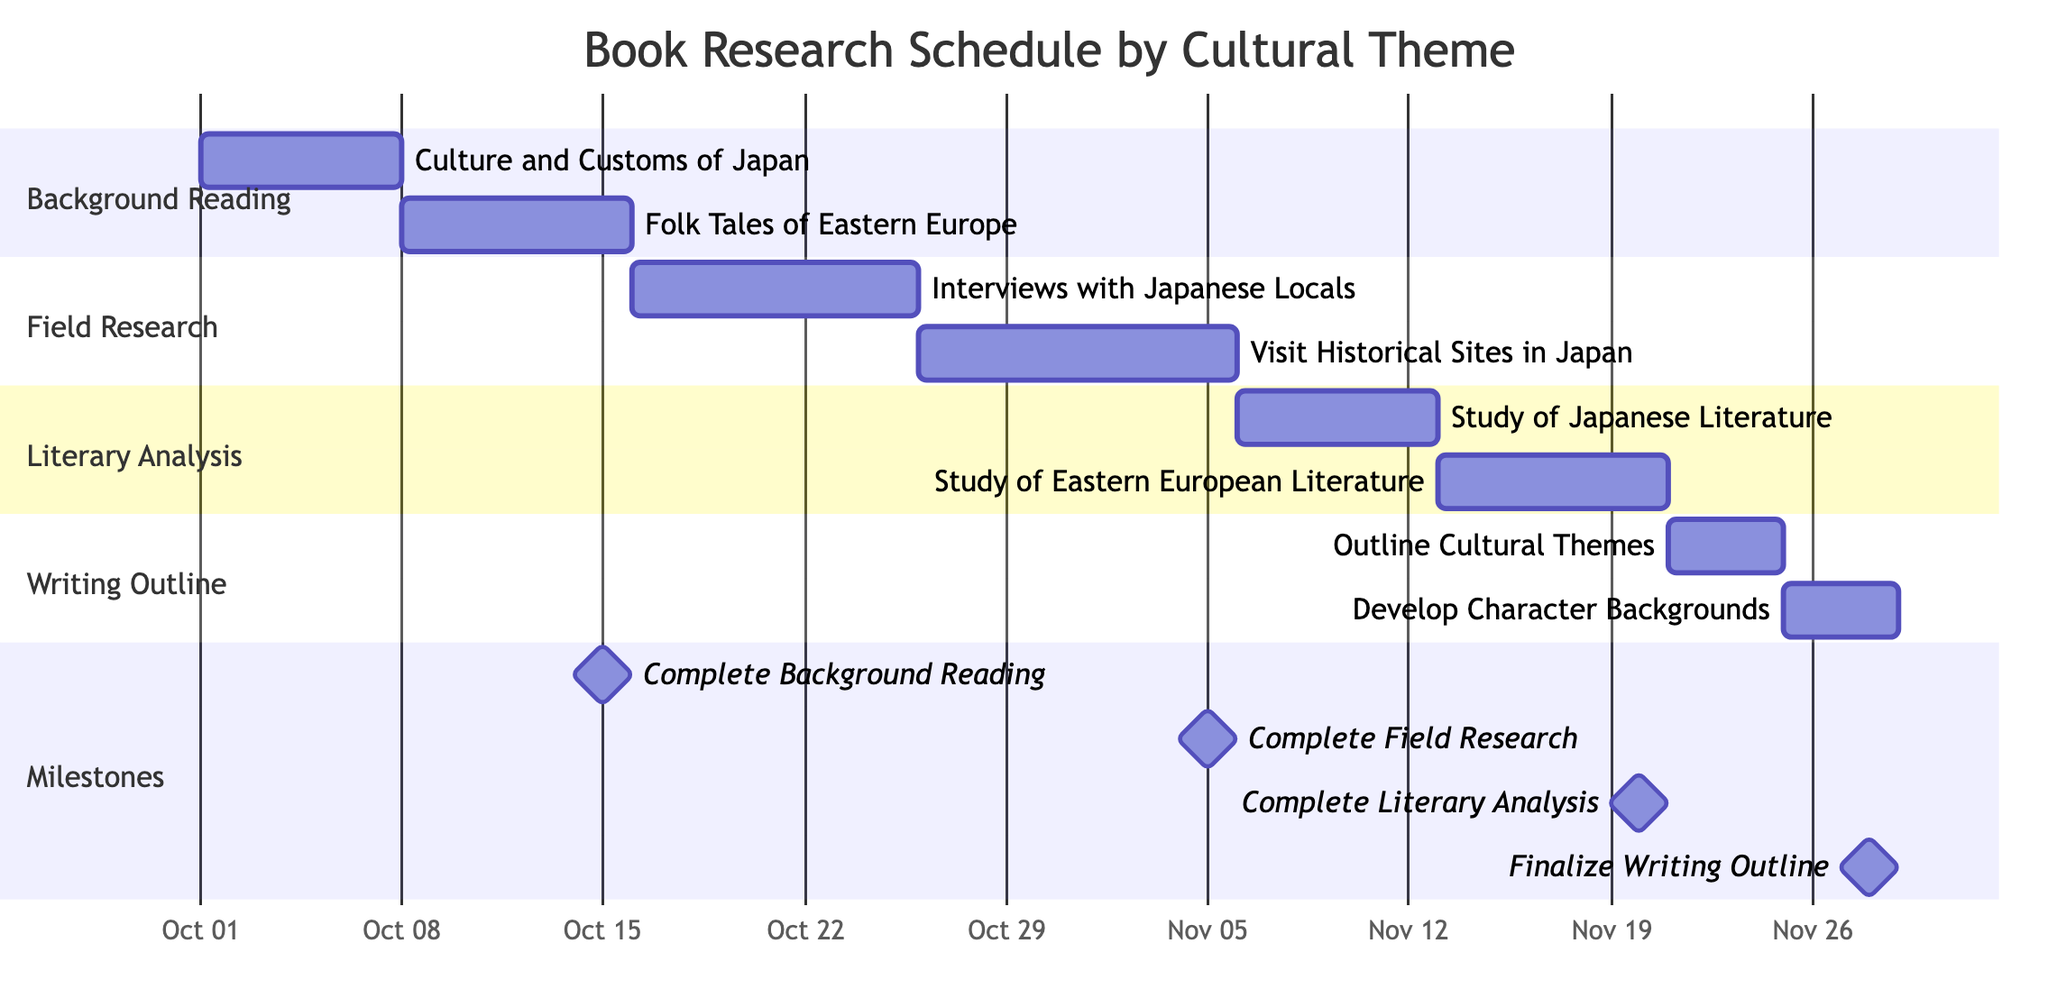What is the duration of the "Background Reading" task? The "Background Reading" task starts on October 1, 2023, and ends on October 15, 2023. To find the duration, we calculate the difference: October 15 - October 1 = 14 days.
Answer: 14 days What are the two subtasks under "Field Research"? The subtasks under "Field Research" are shown as distinct tasks: "Interviews with Japanese Locals" and "Visit Historical Sites in Japan." They are directly listed under the "Field Research" section.
Answer: Interviews with Japanese Locals, Visit Historical Sites in Japan What is the completion date for the "Complete Literary Analysis" milestone? The milestone "Complete Literary Analysis" is clearly indicated with a specific date. According to the diagram, it is set for November 20, 2023.
Answer: November 20, 2023 How many total tasks are there in the “Writing Outline” section? In the "Writing Outline" section, there are two listed tasks: "Outline Cultural Themes" and "Develop Character Backgrounds." This total is simply counted from the entries under that section.
Answer: 2 What is the earliest start date among all tasks? By reviewing all the start dates listed: October 1 (Background Reading), October 16 (Field Research), November 6 (Literary Analysis), and November 21 (Writing Outline), the earliest date is October 1, 2023.
Answer: October 1, 2023 Which subtask finishes last in the overall schedule? To identify the last finishing subtask, we examine all end dates. The last subtask is "Develop Character Backgrounds," which ends on November 28, 2023, noted in the "Writing Outline" section.
Answer: November 28, 2023 How many days does the "Interviews with Japanese Locals" task last? The task "Interviews with Japanese Locals" begins on October 16, 2023, and concludes on October 25, 2023. The duration is calculated as October 25 - October 16, yielding a total of 10 days.
Answer: 10 days What task overlaps with the "Study of Japanese Literature"? By looking at the timeline, note that "Study of Japanese Literature" runs from November 6 to November 12, 2023. The following task, "Study of Eastern European Literature," begins on November 13 and overlaps with no others in the scheduled sections. Therefore, it does not overlap with the preceding tasks.
Answer: None 